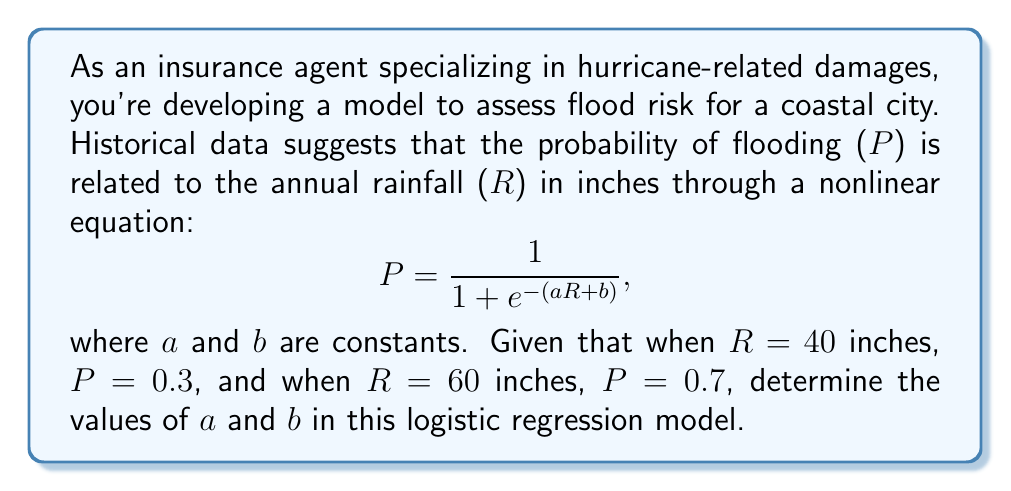Can you answer this question? To solve this problem, we'll use the logistic regression equation and the given data points to create a system of equations:

1) For R = 40 and P = 0.3:
   $$0.3 = \frac{1}{1 + e^{-(40a + b)}}$$

2) For R = 60 and P = 0.7:
   $$0.7 = \frac{1}{1 + e^{-(60a + b)}}$$

3) Let's simplify the first equation:
   $$0.3(1 + e^{-(40a + b)}) = 1$$
   $$1 + e^{-(40a + b)} = \frac{10}{3}$$
   $$e^{-(40a + b)} = \frac{7}{3}$$
   $$-(40a + b) = \ln(\frac{7}{3})$$
   $$40a + b = -\ln(\frac{7}{3})$$

4) Similarly, for the second equation:
   $$0.7(1 + e^{-(60a + b)}) = 1$$
   $$1 + e^{-(60a + b)} = \frac{10}{7}$$
   $$e^{-(60a + b)} = \frac{3}{7}$$
   $$-(60a + b) = \ln(\frac{3}{7})$$
   $$60a + b = -\ln(\frac{3}{7})$$

5) Now we have a system of two linear equations:
   $$40a + b = -\ln(\frac{7}{3})$$
   $$60a + b = -\ln(\frac{3}{7})$$

6) Subtracting the first equation from the second:
   $$20a = -\ln(\frac{3}{7}) + \ln(\frac{7}{3}) = \ln(\frac{3}{7} \cdot \frac{7}{3}) = \ln(1) = 0$$

7) Solving for a:
   $$a = \frac{0}{20} = 0$$

8) Substituting a = 0 into either of the original equations:
   $$b = -\ln(\frac{7}{3}) \approx -0.847$$

Therefore, a ≈ 0 and b ≈ -0.847.
Answer: a ≈ 0, b ≈ -0.847 